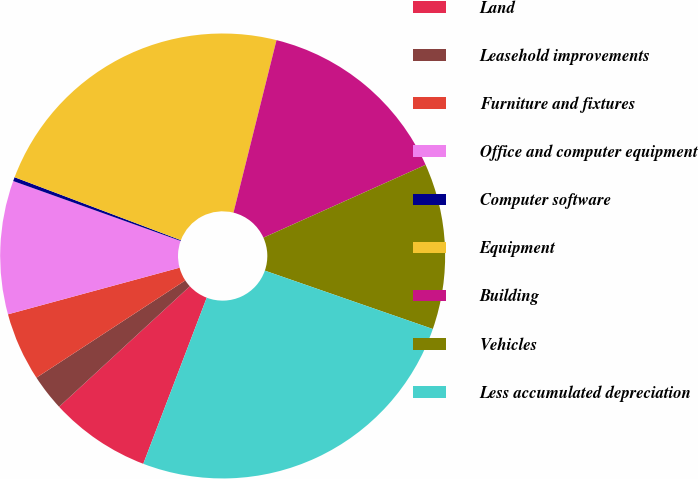<chart> <loc_0><loc_0><loc_500><loc_500><pie_chart><fcel>Land<fcel>Leasehold improvements<fcel>Furniture and fixtures<fcel>Office and computer equipment<fcel>Computer software<fcel>Equipment<fcel>Building<fcel>Vehicles<fcel>Less accumulated depreciation<nl><fcel>7.34%<fcel>2.64%<fcel>4.99%<fcel>9.69%<fcel>0.29%<fcel>23.13%<fcel>14.39%<fcel>12.04%<fcel>25.48%<nl></chart> 